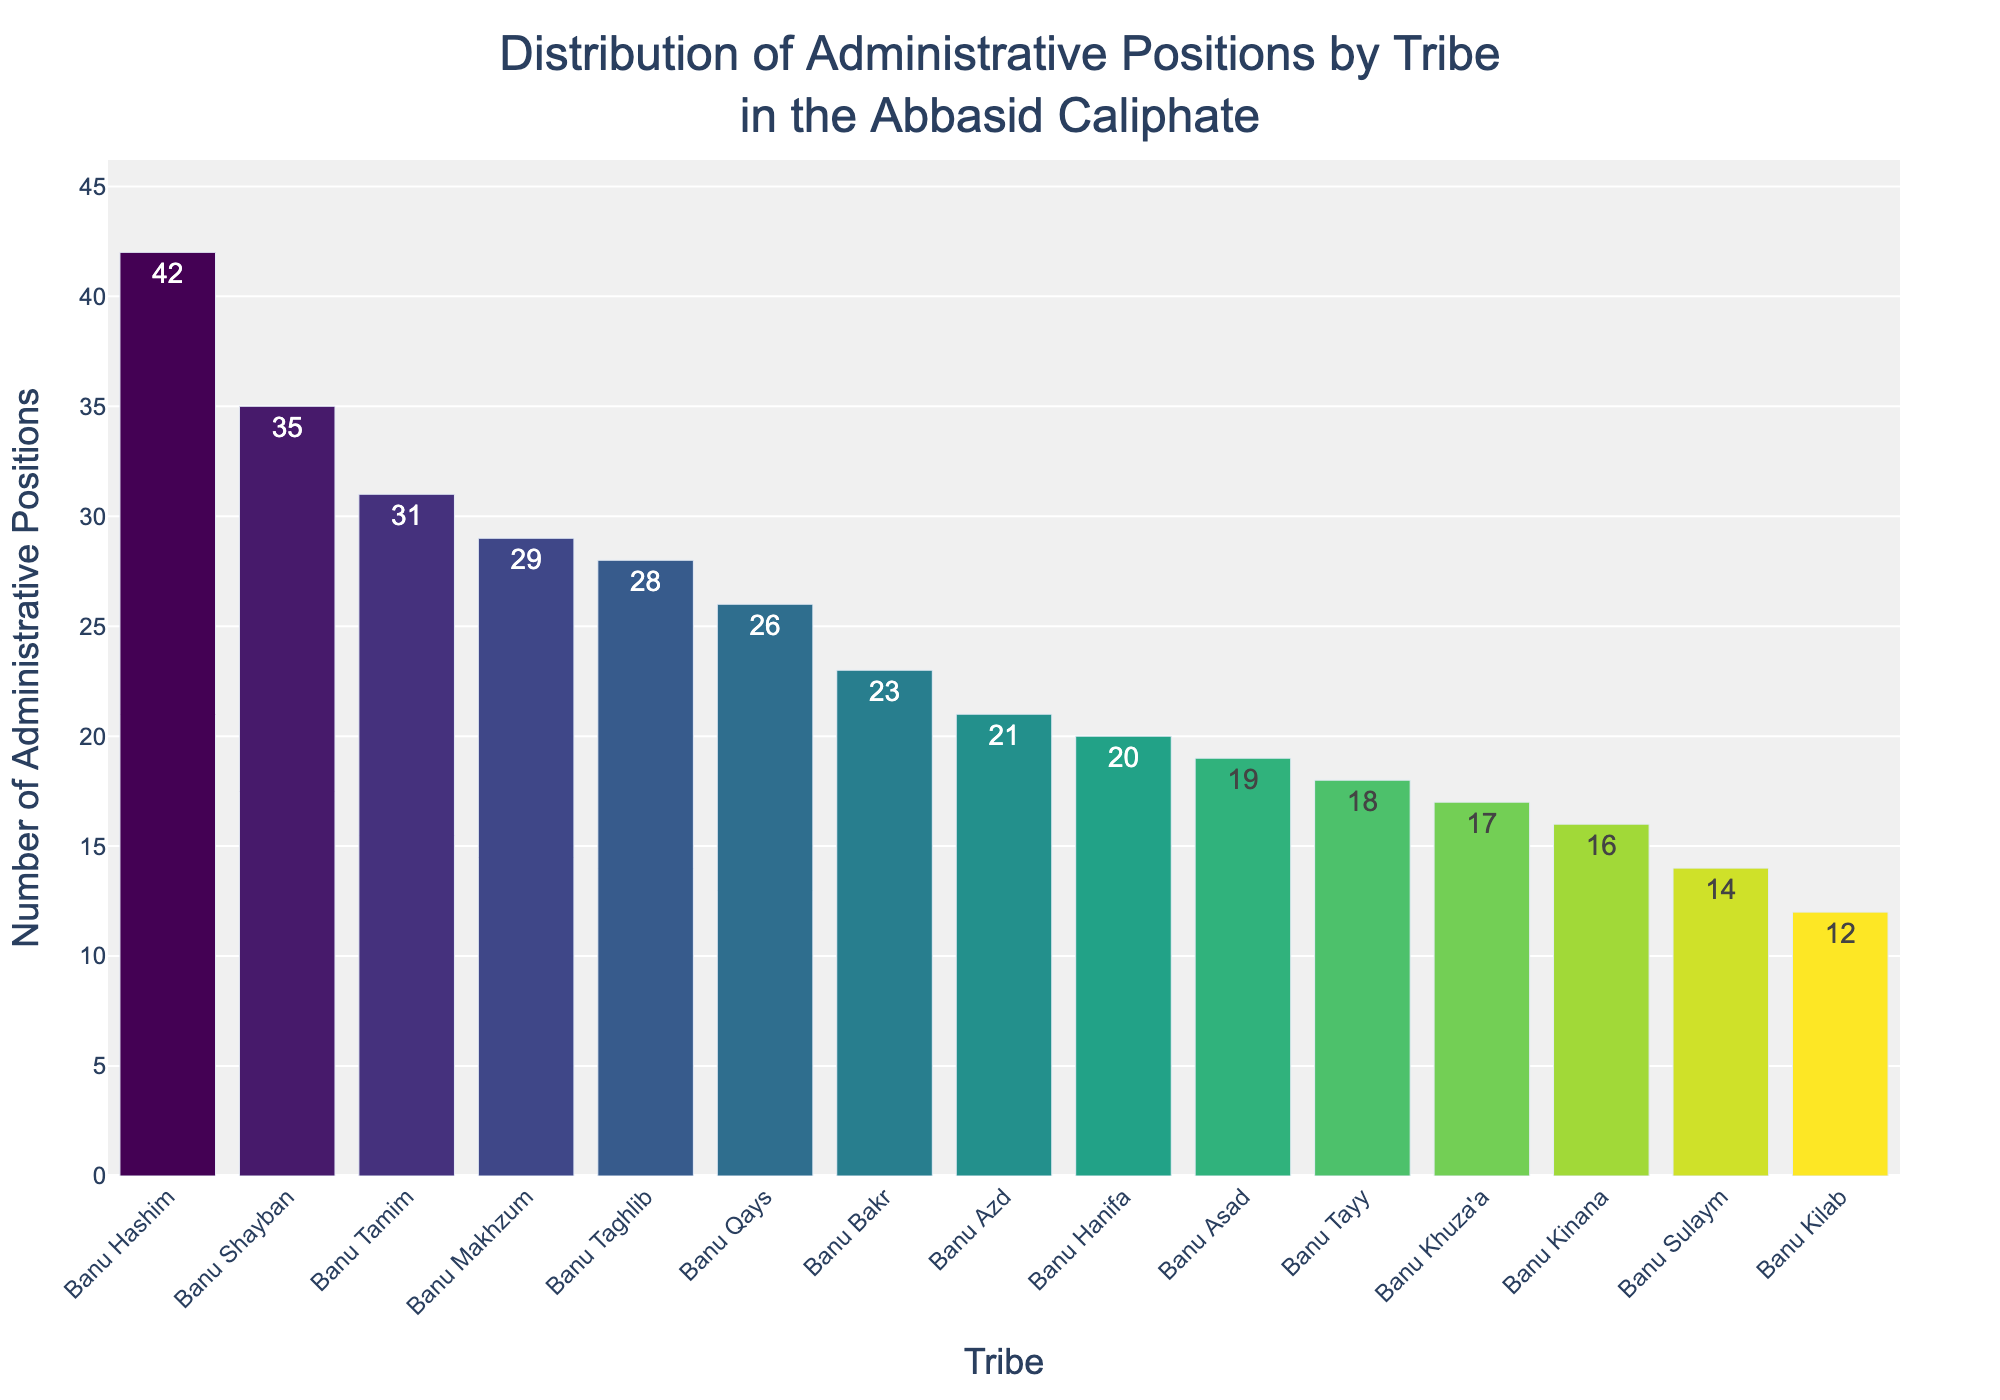What's the tribe with the highest number of administrative positions? To identify the tribe with the highest number of administrative positions, look for the tallest bar in the chart. The tribe corresponding to this bar is Banu Hashim, with 42 positions.
Answer: Banu Hashim Which tribe holds the fewest administrative positions, and how many positions do they hold? The tribe with the fewest administrative positions is represented by the shortest bar in the chart. This tribe is Banu Kilab, with 12 positions.
Answer: Banu Kilab, 12 What is the visual difference in the height of the bars between Banu Hashim and Banu Asad? To determine the visual difference, observe the height of the bars for Banu Hashim and Banu Asad. Banu Hashim has 42 positions and Banu Asad has 19 positions. The difference in height is 42 - 19.
Answer: 23 Which tribes have administrative positions greater than 30? To identify tribes with more than 30 positions, look at bars that extend beyond the corresponding y-axis value of 30. These tribes are Banu Hashim (42), Banu Shayban (35), Banu Tamim (31), and Banu Makhzum (29).
Answer: Banu Hashim, Banu Shayban, Banu Tamim, Banu Makhzum How many tribes have 20 or more administrative positions but less than 30? To find this, count the bars with heights between 20 and 30 (inclusive for 20, exclusive for 30). These tribes are Banu Taghlib (28), Banu Tamim (31), Banu Khuza'a (17), and Banu Qays (26).
Answer: 4 What's the combined number of administrative positions held by Banu Bakr and Banu Khuza'a? Add the number of positions held by Banu Bakr (23) and Banu Khuza'a (17) together. The combined total is 23 + 17.
Answer: 40 Which tribe ranks fifth in terms of the number of administrative positions? Rank the tribes by the height of their bars in descending order. The tribe in the fifth position is Banu Tamim with 31 positions.
Answer: Banu Tamim Compare the administrative positions of Banu Tayy and Banu Hanifa. Which tribe holds more positions, and by how much? Observe the heights of the bars for Banu Tayy (18) and Banu Hanifa (20). Banu Hanifa holds more positions, with a difference of 20 - 18.
Answer: Banu Hanifa, 2 What is the median number of administrative positions held by the tribes? To find the median, first list the number of positions in ascending order: [12, 14, 16, 17, 18, 19, 20, 21, 23, 26, 28, 29, 31, 35, 42]. The median is the middle value in this list. The median value is the 8th number, which is 21.
Answer: 21 What's the average number of administrative positions held by all tribes? Add all the administrative positions together and divide by the number of tribes. Sum: 42 + 28 + 35 + 31 + 19 + 23 + 17 + 26 + 14 + 21 + 12 + 29 + 16 + 20 + 18 = 351. There are 15 tribes, so the average is 351 / 15.
Answer: 23.4 